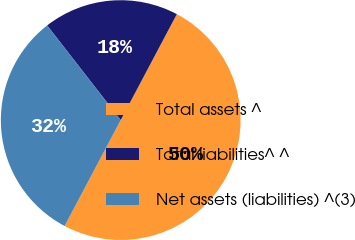Convert chart. <chart><loc_0><loc_0><loc_500><loc_500><pie_chart><fcel>Total assets ^<fcel>Total liabilities^ ^<fcel>Net assets (liabilities) ^(3)<nl><fcel>50.0%<fcel>18.27%<fcel>31.73%<nl></chart> 